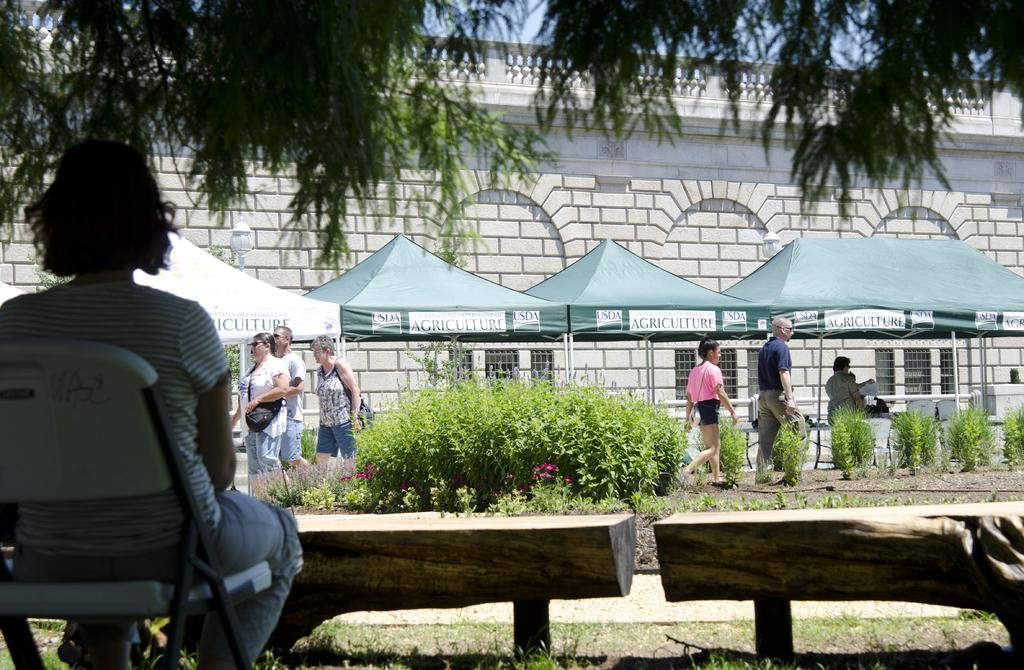Where is the woman located in the image? The woman is sitting on a chair on the left side of the image. What is in front of the woman? There are wooden benches in front of the woman. What type of vegetation can be seen in the image? Plants are present in the image. What are the people in the image doing? People are walking in the image. What type of temporary shelter is visible in the image? There are tents in the image. What is the background of the image made of? There is a wall visible in the image. What part of the natural environment is visible in the image? The sky is visible in the image. What type of tree is present in the image? There is a tree in the image. What type of ground cover is present in the image? Grass is present in the image. What type of wax can be seen dripping from the tree in the image? There is no wax present in the image, nor is there any indication of wax dripping from the tree. 